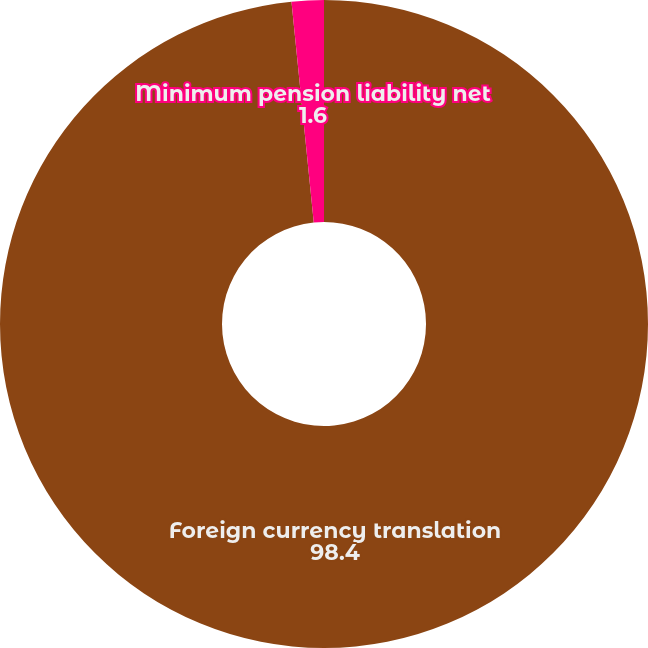Convert chart. <chart><loc_0><loc_0><loc_500><loc_500><pie_chart><fcel>Foreign currency translation<fcel>Minimum pension liability net<nl><fcel>98.4%<fcel>1.6%<nl></chart> 